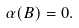<formula> <loc_0><loc_0><loc_500><loc_500>\alpha ( B ) = 0 .</formula> 